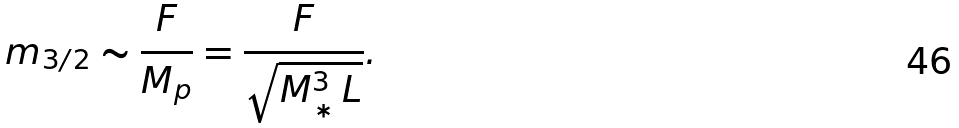<formula> <loc_0><loc_0><loc_500><loc_500>m _ { 3 / 2 } \sim \frac { F } { M _ { p } } = \frac { F } { \sqrt { M _ { * } ^ { 3 } \, L } } .</formula> 